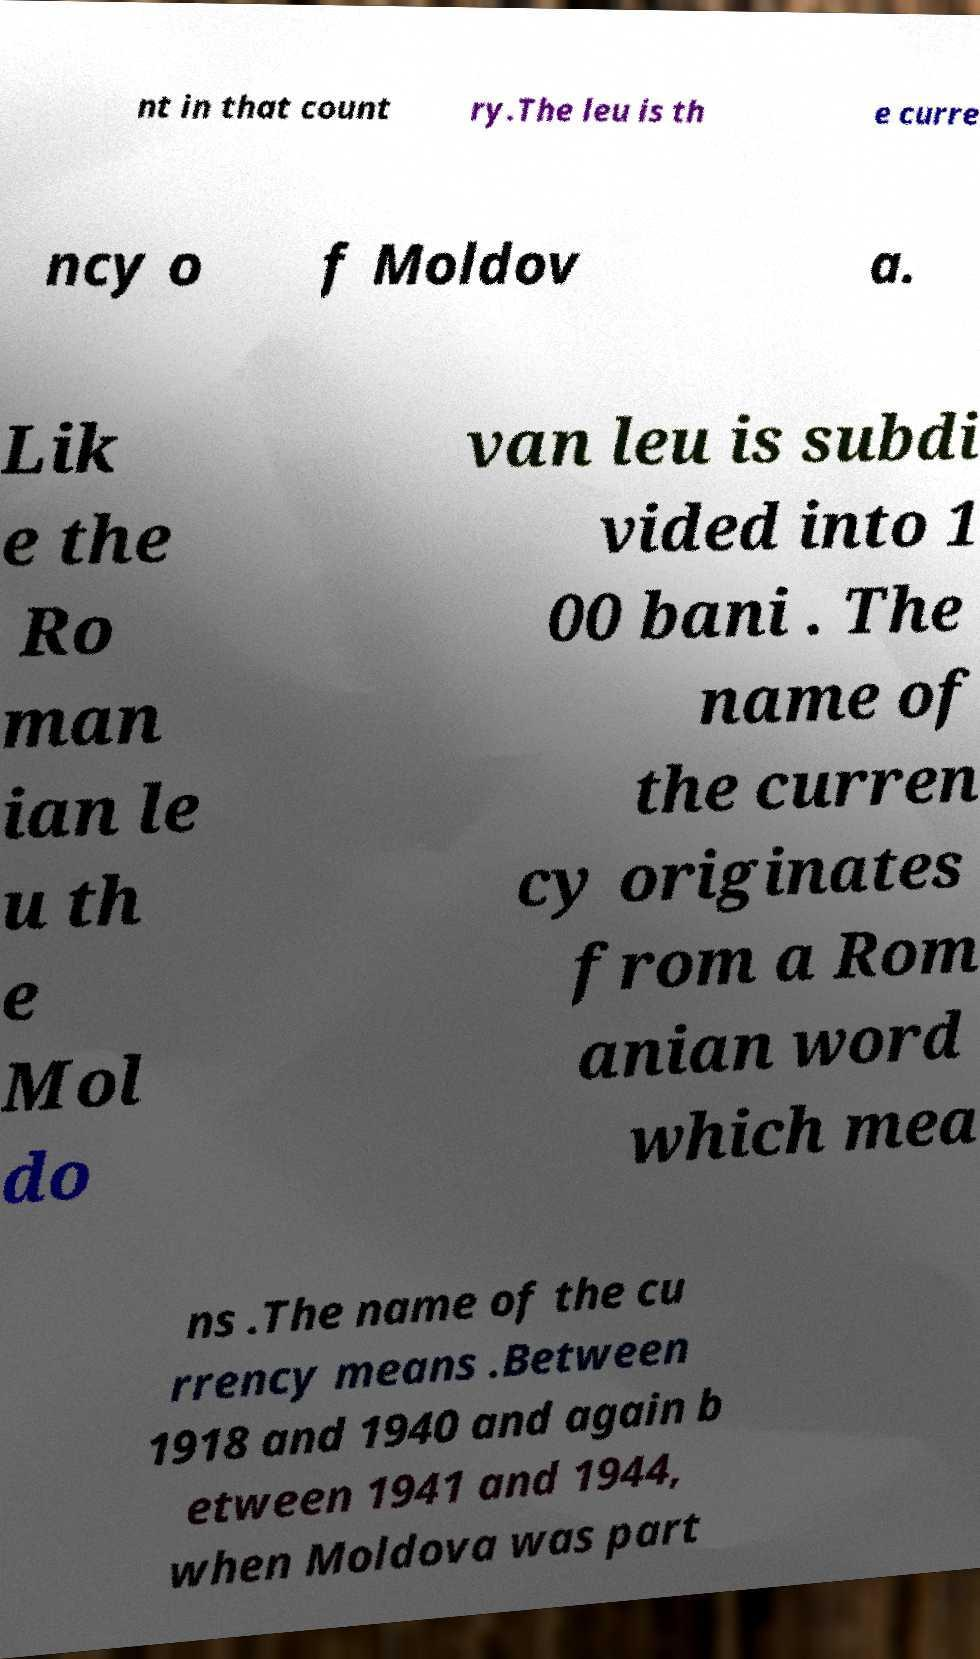There's text embedded in this image that I need extracted. Can you transcribe it verbatim? nt in that count ry.The leu is th e curre ncy o f Moldov a. Lik e the Ro man ian le u th e Mol do van leu is subdi vided into 1 00 bani . The name of the curren cy originates from a Rom anian word which mea ns .The name of the cu rrency means .Between 1918 and 1940 and again b etween 1941 and 1944, when Moldova was part 